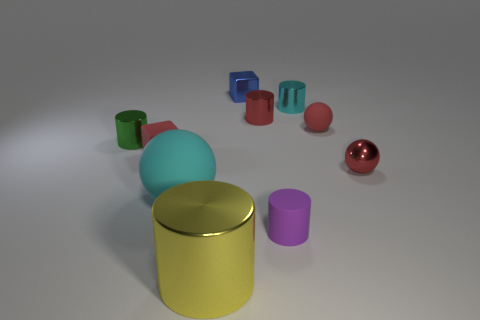Does the image have any sort of symmetry or pattern? The image does not exhibit a strict symmetry or a repeating pattern, rather it shows an asymmetrical composition with a random distribution of objects. The variety in color, size, and position of the objects creates a visually interesting scene without a discernible pattern or symmetry. 